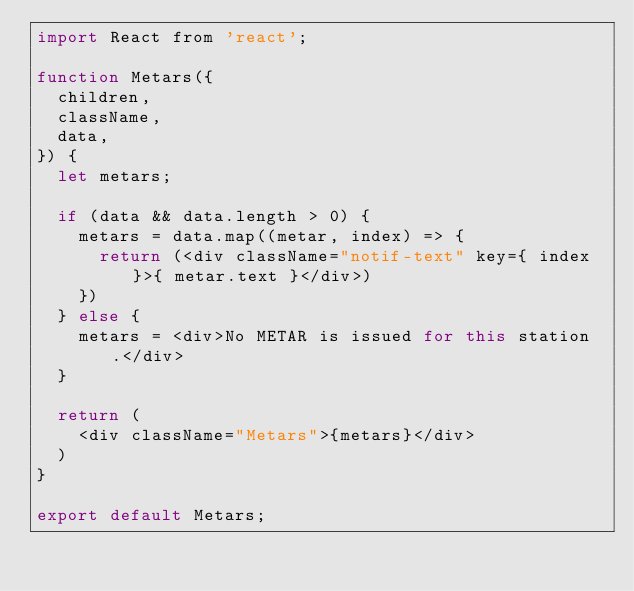<code> <loc_0><loc_0><loc_500><loc_500><_JavaScript_>import React from 'react';

function Metars({
  children,
  className,
  data,
}) {
  let metars;

  if (data && data.length > 0) {
    metars = data.map((metar, index) => {
      return (<div className="notif-text" key={ index }>{ metar.text }</div>)
    })
  } else {
    metars = <div>No METAR is issued for this station.</div>
  }

  return (
    <div className="Metars">{metars}</div>
  )
}

export default Metars;
</code> 